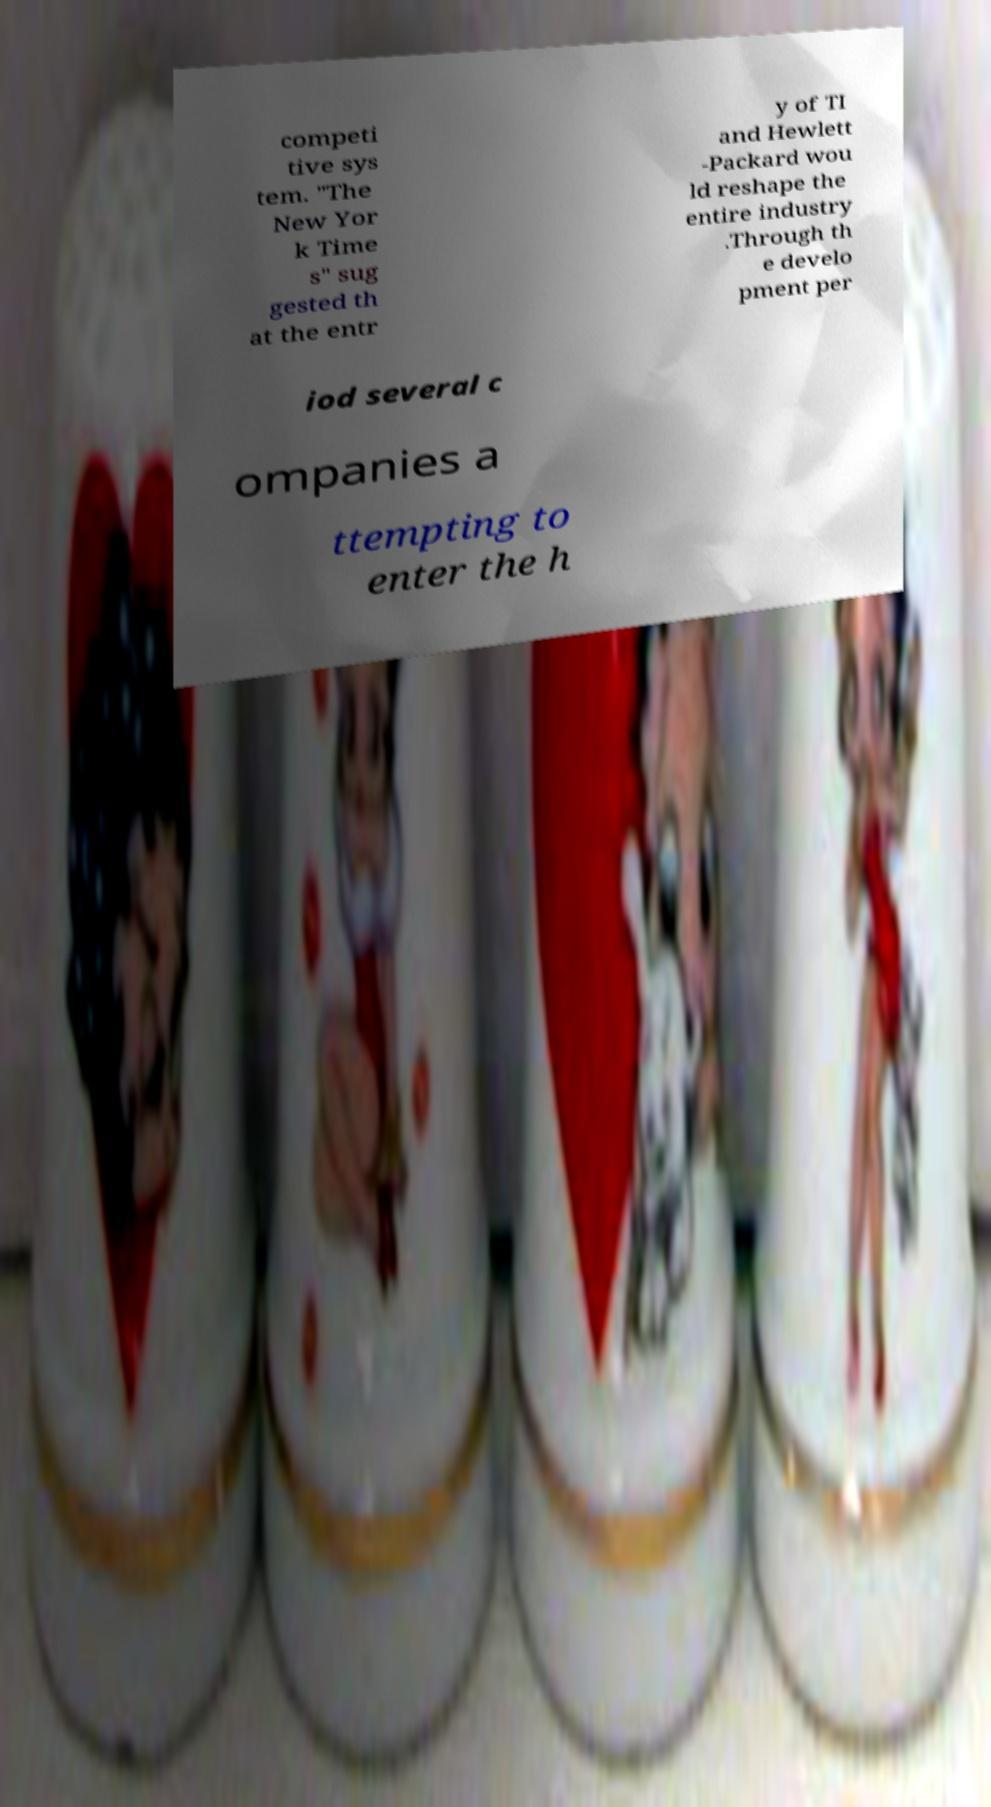I need the written content from this picture converted into text. Can you do that? competi tive sys tem. "The New Yor k Time s" sug gested th at the entr y of TI and Hewlett -Packard wou ld reshape the entire industry .Through th e develo pment per iod several c ompanies a ttempting to enter the h 